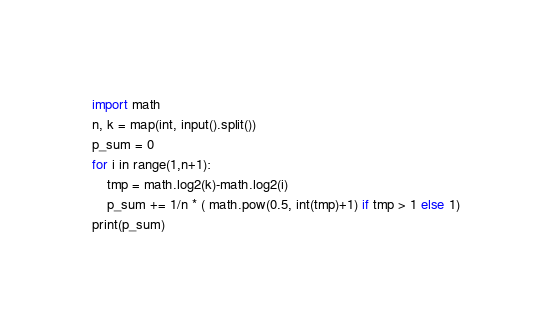<code> <loc_0><loc_0><loc_500><loc_500><_Python_>import math
n, k = map(int, input().split())
p_sum = 0
for i in range(1,n+1):
    tmp = math.log2(k)-math.log2(i)
    p_sum += 1/n * ( math.pow(0.5, int(tmp)+1) if tmp > 1 else 1)
print(p_sum)</code> 